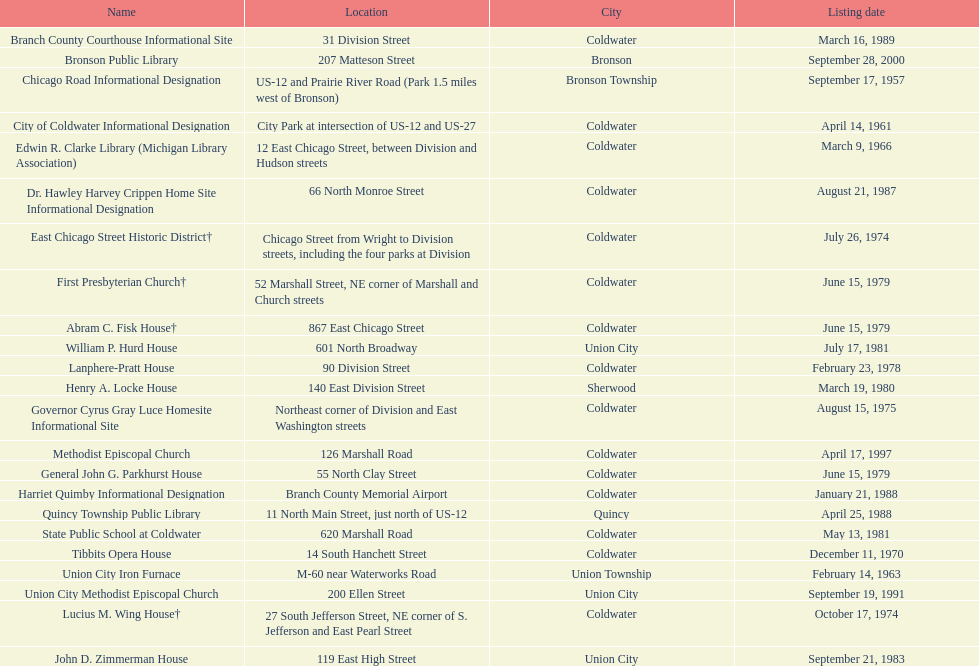How many historic sites were listed before 1965? 3. 